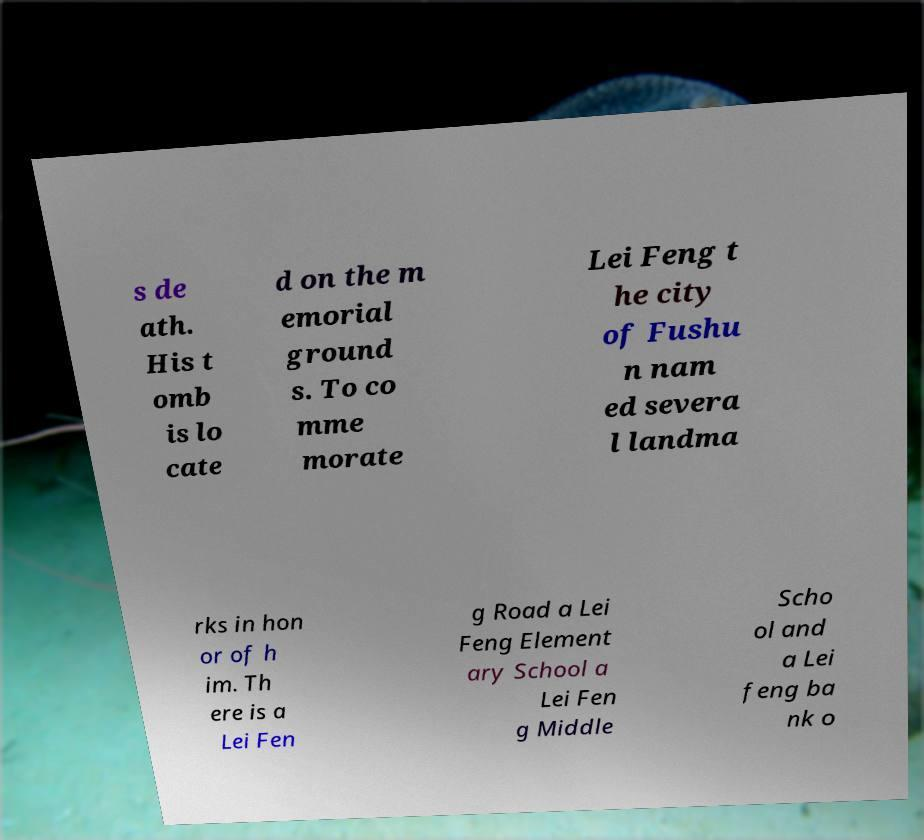Can you accurately transcribe the text from the provided image for me? s de ath. His t omb is lo cate d on the m emorial ground s. To co mme morate Lei Feng t he city of Fushu n nam ed severa l landma rks in hon or of h im. Th ere is a Lei Fen g Road a Lei Feng Element ary School a Lei Fen g Middle Scho ol and a Lei feng ba nk o 